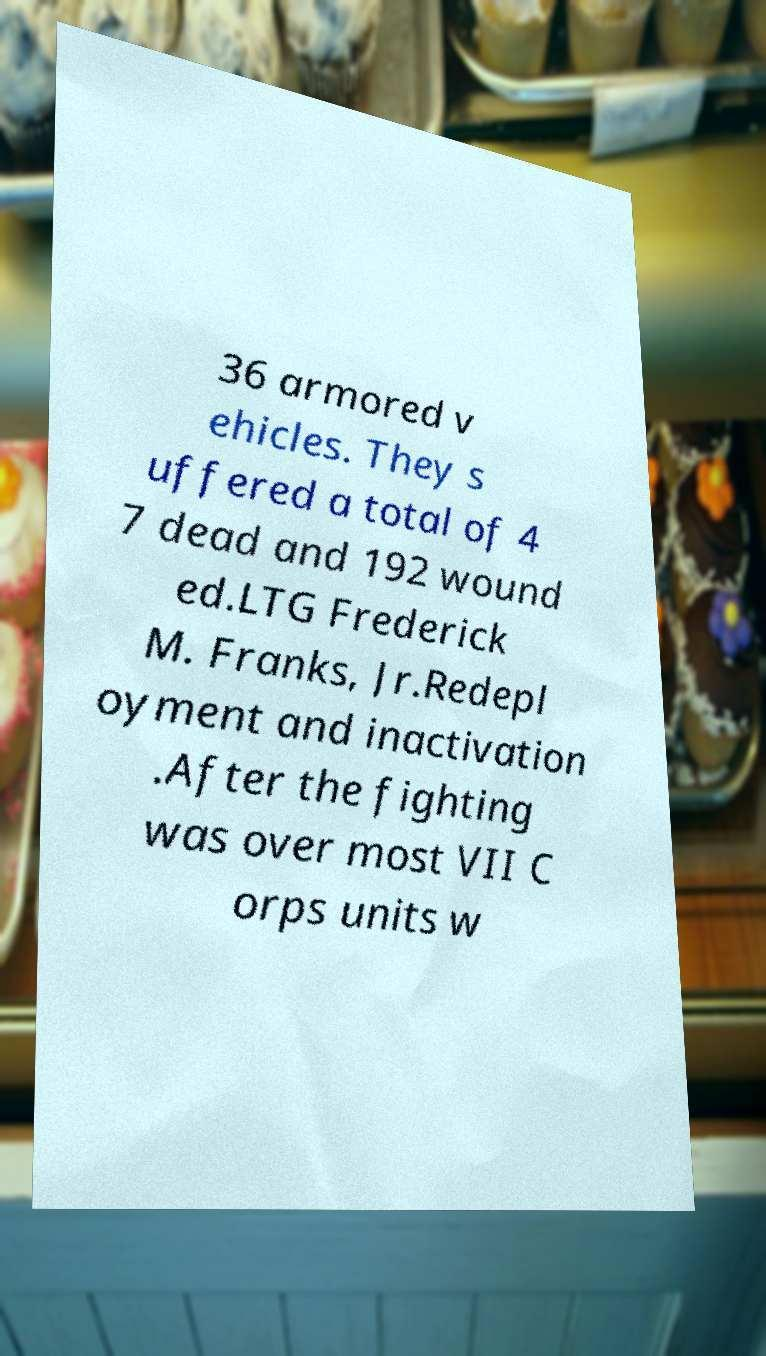Could you assist in decoding the text presented in this image and type it out clearly? 36 armored v ehicles. They s uffered a total of 4 7 dead and 192 wound ed.LTG Frederick M. Franks, Jr.Redepl oyment and inactivation .After the fighting was over most VII C orps units w 